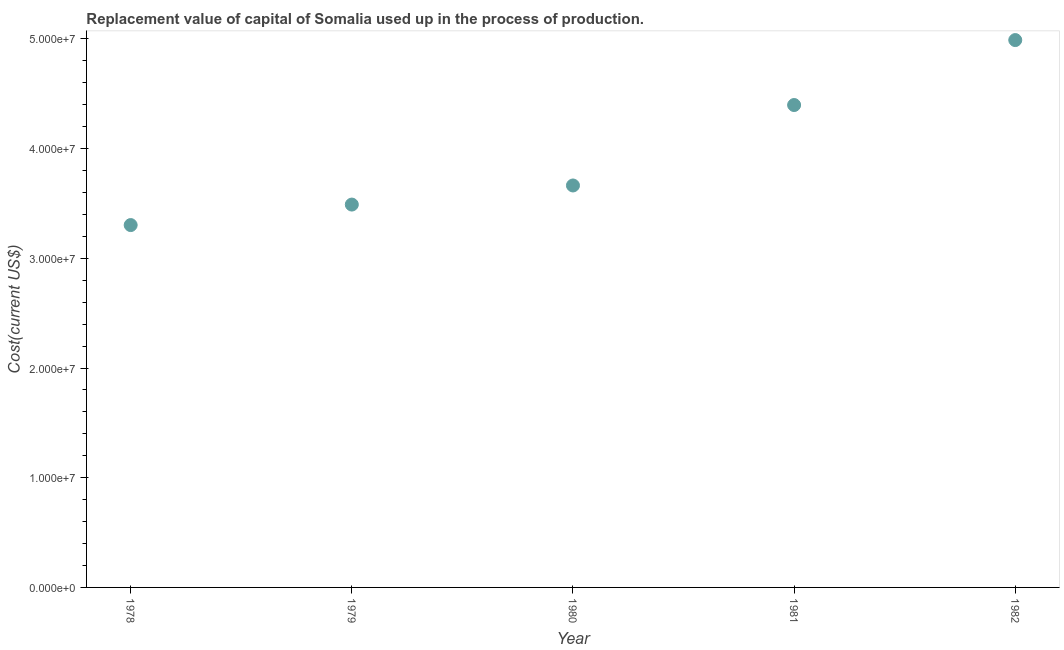What is the consumption of fixed capital in 1980?
Provide a short and direct response. 3.66e+07. Across all years, what is the maximum consumption of fixed capital?
Your response must be concise. 4.99e+07. Across all years, what is the minimum consumption of fixed capital?
Give a very brief answer. 3.30e+07. In which year was the consumption of fixed capital minimum?
Provide a short and direct response. 1978. What is the sum of the consumption of fixed capital?
Provide a short and direct response. 1.98e+08. What is the difference between the consumption of fixed capital in 1978 and 1979?
Give a very brief answer. -1.87e+06. What is the average consumption of fixed capital per year?
Your response must be concise. 3.97e+07. What is the median consumption of fixed capital?
Give a very brief answer. 3.66e+07. In how many years, is the consumption of fixed capital greater than 38000000 US$?
Provide a short and direct response. 2. Do a majority of the years between 1982 and 1978 (inclusive) have consumption of fixed capital greater than 34000000 US$?
Offer a terse response. Yes. What is the ratio of the consumption of fixed capital in 1978 to that in 1982?
Your answer should be very brief. 0.66. Is the consumption of fixed capital in 1979 less than that in 1980?
Give a very brief answer. Yes. What is the difference between the highest and the second highest consumption of fixed capital?
Offer a very short reply. 5.92e+06. What is the difference between the highest and the lowest consumption of fixed capital?
Give a very brief answer. 1.69e+07. How many dotlines are there?
Your answer should be compact. 1. Are the values on the major ticks of Y-axis written in scientific E-notation?
Your answer should be compact. Yes. Does the graph contain grids?
Provide a succinct answer. No. What is the title of the graph?
Make the answer very short. Replacement value of capital of Somalia used up in the process of production. What is the label or title of the X-axis?
Provide a succinct answer. Year. What is the label or title of the Y-axis?
Ensure brevity in your answer.  Cost(current US$). What is the Cost(current US$) in 1978?
Ensure brevity in your answer.  3.30e+07. What is the Cost(current US$) in 1979?
Ensure brevity in your answer.  3.49e+07. What is the Cost(current US$) in 1980?
Give a very brief answer. 3.66e+07. What is the Cost(current US$) in 1981?
Your response must be concise. 4.40e+07. What is the Cost(current US$) in 1982?
Provide a succinct answer. 4.99e+07. What is the difference between the Cost(current US$) in 1978 and 1979?
Your answer should be very brief. -1.87e+06. What is the difference between the Cost(current US$) in 1978 and 1980?
Your answer should be very brief. -3.61e+06. What is the difference between the Cost(current US$) in 1978 and 1981?
Offer a terse response. -1.09e+07. What is the difference between the Cost(current US$) in 1978 and 1982?
Offer a very short reply. -1.69e+07. What is the difference between the Cost(current US$) in 1979 and 1980?
Your answer should be very brief. -1.74e+06. What is the difference between the Cost(current US$) in 1979 and 1981?
Offer a very short reply. -9.07e+06. What is the difference between the Cost(current US$) in 1979 and 1982?
Make the answer very short. -1.50e+07. What is the difference between the Cost(current US$) in 1980 and 1981?
Provide a succinct answer. -7.33e+06. What is the difference between the Cost(current US$) in 1980 and 1982?
Keep it short and to the point. -1.33e+07. What is the difference between the Cost(current US$) in 1981 and 1982?
Give a very brief answer. -5.92e+06. What is the ratio of the Cost(current US$) in 1978 to that in 1979?
Your answer should be compact. 0.95. What is the ratio of the Cost(current US$) in 1978 to that in 1980?
Your response must be concise. 0.9. What is the ratio of the Cost(current US$) in 1978 to that in 1981?
Your response must be concise. 0.75. What is the ratio of the Cost(current US$) in 1978 to that in 1982?
Make the answer very short. 0.66. What is the ratio of the Cost(current US$) in 1979 to that in 1980?
Your answer should be very brief. 0.95. What is the ratio of the Cost(current US$) in 1979 to that in 1981?
Provide a short and direct response. 0.79. What is the ratio of the Cost(current US$) in 1979 to that in 1982?
Offer a terse response. 0.7. What is the ratio of the Cost(current US$) in 1980 to that in 1981?
Offer a terse response. 0.83. What is the ratio of the Cost(current US$) in 1980 to that in 1982?
Make the answer very short. 0.73. What is the ratio of the Cost(current US$) in 1981 to that in 1982?
Ensure brevity in your answer.  0.88. 